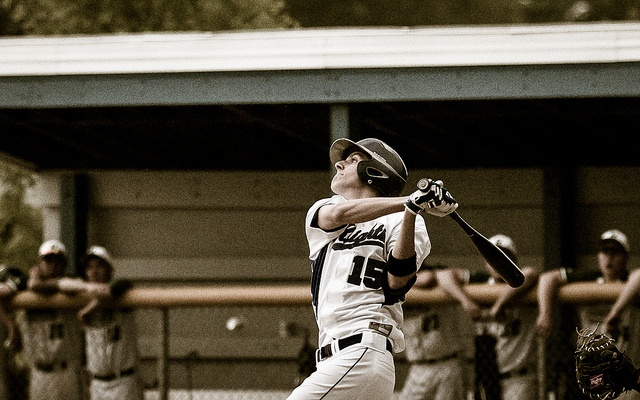Describe the objects in this image and their specific colors. I can see people in black, lightgray, darkgray, and gray tones, people in black and gray tones, people in black and gray tones, people in black and gray tones, and people in black and gray tones in this image. 